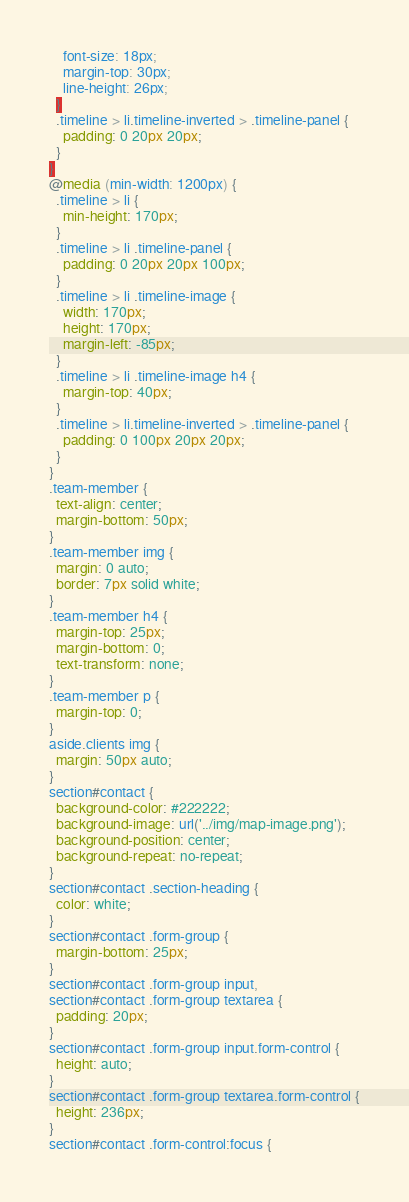<code> <loc_0><loc_0><loc_500><loc_500><_CSS_>    font-size: 18px;
    margin-top: 30px;
    line-height: 26px;
  }
  .timeline > li.timeline-inverted > .timeline-panel {
    padding: 0 20px 20px;
  }
}
@media (min-width: 1200px) {
  .timeline > li {
    min-height: 170px;
  }
  .timeline > li .timeline-panel {
    padding: 0 20px 20px 100px;
  }
  .timeline > li .timeline-image {
    width: 170px;
    height: 170px;
    margin-left: -85px;
  }
  .timeline > li .timeline-image h4 {
    margin-top: 40px;
  }
  .timeline > li.timeline-inverted > .timeline-panel {
    padding: 0 100px 20px 20px;
  }
}
.team-member {
  text-align: center;
  margin-bottom: 50px;
}
.team-member img {
  margin: 0 auto;
  border: 7px solid white;
}
.team-member h4 {
  margin-top: 25px;
  margin-bottom: 0;
  text-transform: none;
}
.team-member p {
  margin-top: 0;
}
aside.clients img {
  margin: 50px auto;
}
section#contact {
  background-color: #222222;
  background-image: url('../img/map-image.png');
  background-position: center;
  background-repeat: no-repeat;
}
section#contact .section-heading {
  color: white;
}
section#contact .form-group {
  margin-bottom: 25px;
}
section#contact .form-group input,
section#contact .form-group textarea {
  padding: 20px;
}
section#contact .form-group input.form-control {
  height: auto;
}
section#contact .form-group textarea.form-control {
  height: 236px;
}
section#contact .form-control:focus {</code> 